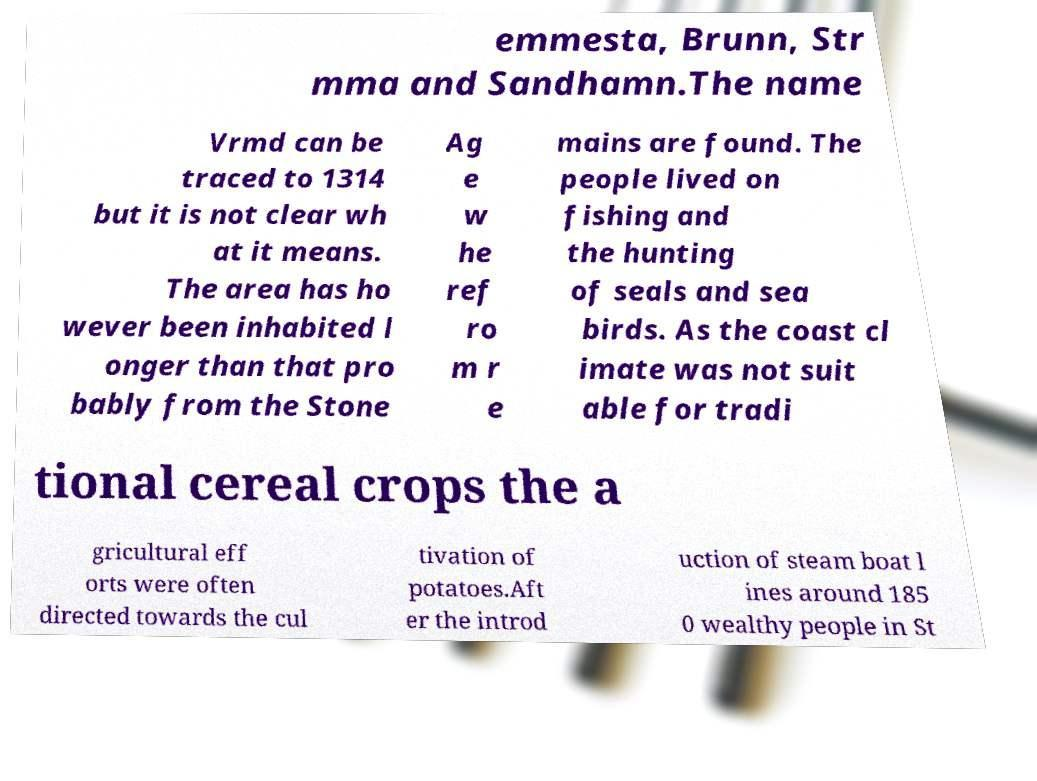There's text embedded in this image that I need extracted. Can you transcribe it verbatim? emmesta, Brunn, Str mma and Sandhamn.The name Vrmd can be traced to 1314 but it is not clear wh at it means. The area has ho wever been inhabited l onger than that pro bably from the Stone Ag e w he ref ro m r e mains are found. The people lived on fishing and the hunting of seals and sea birds. As the coast cl imate was not suit able for tradi tional cereal crops the a gricultural eff orts were often directed towards the cul tivation of potatoes.Aft er the introd uction of steam boat l ines around 185 0 wealthy people in St 